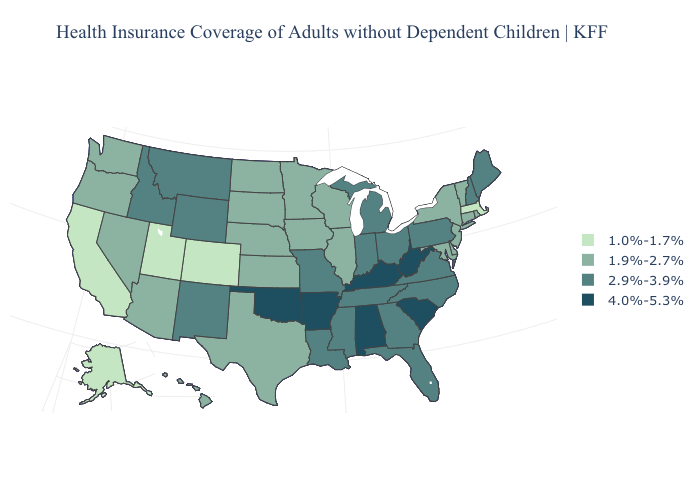Name the states that have a value in the range 1.9%-2.7%?
Be succinct. Arizona, Connecticut, Delaware, Hawaii, Illinois, Iowa, Kansas, Maryland, Minnesota, Nebraska, Nevada, New Jersey, New York, North Dakota, Oregon, Rhode Island, South Dakota, Texas, Vermont, Washington, Wisconsin. Does the first symbol in the legend represent the smallest category?
Keep it brief. Yes. Among the states that border Indiana , does Kentucky have the lowest value?
Answer briefly. No. What is the value of Minnesota?
Write a very short answer. 1.9%-2.7%. What is the value of Ohio?
Answer briefly. 2.9%-3.9%. What is the lowest value in the Northeast?
Concise answer only. 1.0%-1.7%. What is the value of Florida?
Quick response, please. 2.9%-3.9%. What is the value of Indiana?
Answer briefly. 2.9%-3.9%. Name the states that have a value in the range 1.0%-1.7%?
Short answer required. Alaska, California, Colorado, Massachusetts, Utah. Name the states that have a value in the range 1.0%-1.7%?
Keep it brief. Alaska, California, Colorado, Massachusetts, Utah. What is the value of Oklahoma?
Quick response, please. 4.0%-5.3%. What is the lowest value in the Northeast?
Give a very brief answer. 1.0%-1.7%. Among the states that border Delaware , which have the highest value?
Answer briefly. Pennsylvania. What is the value of Florida?
Answer briefly. 2.9%-3.9%. 